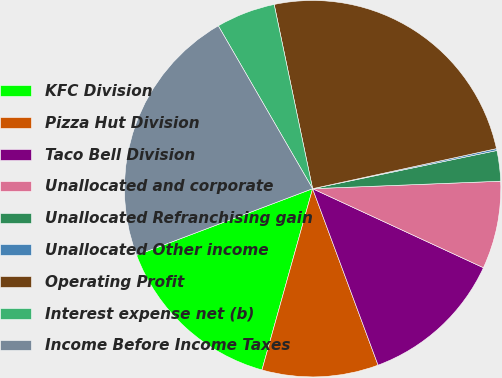Convert chart. <chart><loc_0><loc_0><loc_500><loc_500><pie_chart><fcel>KFC Division<fcel>Pizza Hut Division<fcel>Taco Bell Division<fcel>Unallocated and corporate<fcel>Unallocated Refranchising gain<fcel>Unallocated Other income<fcel>Operating Profit<fcel>Interest expense net (b)<fcel>Income Before Income Taxes<nl><fcel>14.91%<fcel>9.99%<fcel>12.45%<fcel>7.53%<fcel>2.62%<fcel>0.16%<fcel>24.86%<fcel>5.08%<fcel>22.4%<nl></chart> 